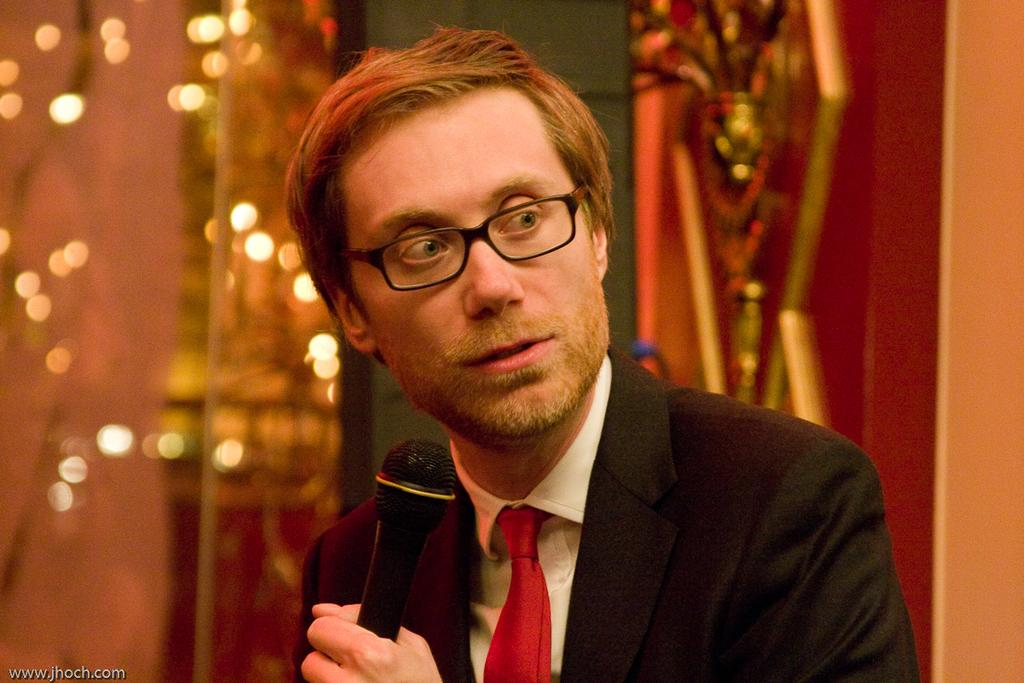What is the man in the image holding? The man is holding a microphone. What can be seen on the man's face in the image? The man is wearing spectacles. What is the man wearing in the image? The man is wearing a black suit. What can be seen in the background of the image? There are lights visible in the background of the image. What is the price of the experience the man is offering in the image? There is no indication of a price or an experience being offered in the image. 